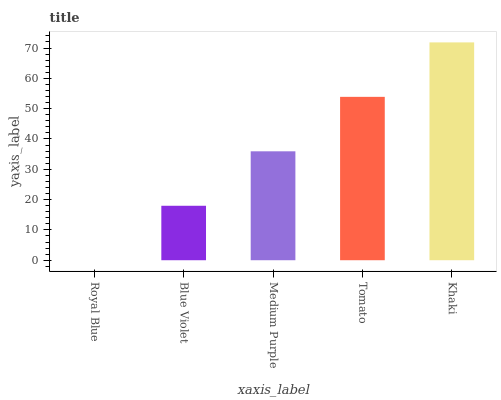Is Royal Blue the minimum?
Answer yes or no. Yes. Is Khaki the maximum?
Answer yes or no. Yes. Is Blue Violet the minimum?
Answer yes or no. No. Is Blue Violet the maximum?
Answer yes or no. No. Is Blue Violet greater than Royal Blue?
Answer yes or no. Yes. Is Royal Blue less than Blue Violet?
Answer yes or no. Yes. Is Royal Blue greater than Blue Violet?
Answer yes or no. No. Is Blue Violet less than Royal Blue?
Answer yes or no. No. Is Medium Purple the high median?
Answer yes or no. Yes. Is Medium Purple the low median?
Answer yes or no. Yes. Is Khaki the high median?
Answer yes or no. No. Is Blue Violet the low median?
Answer yes or no. No. 